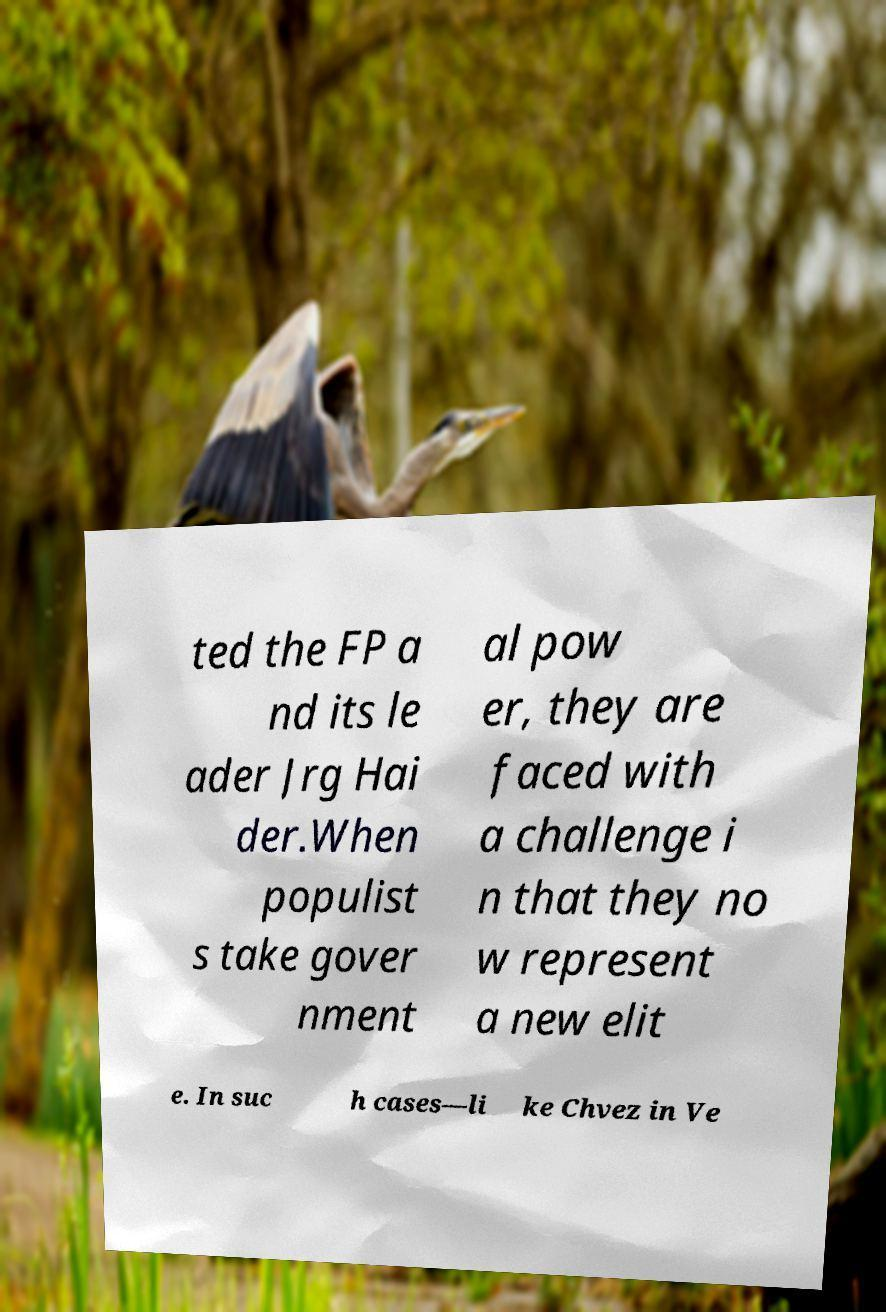I need the written content from this picture converted into text. Can you do that? ted the FP a nd its le ader Jrg Hai der.When populist s take gover nment al pow er, they are faced with a challenge i n that they no w represent a new elit e. In suc h cases—li ke Chvez in Ve 